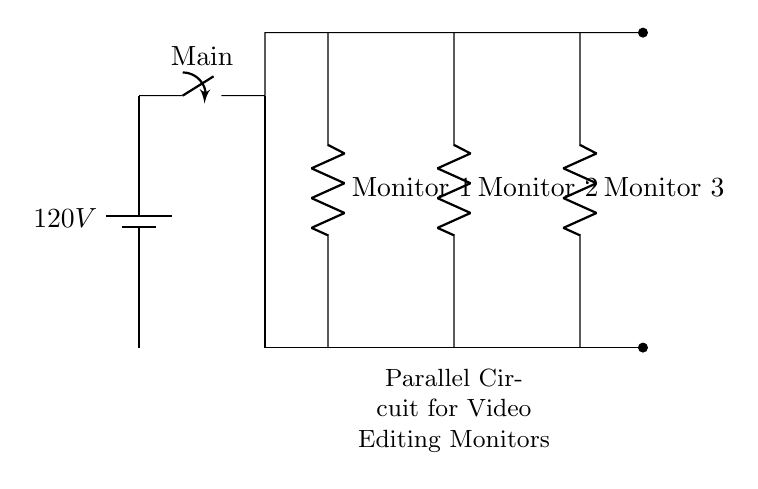What is the voltage of the power supply? The power supply voltage is indicated on the battery symbol in the circuit. It shows that the voltage is 120 volts.
Answer: 120 volts How many monitors are connected in parallel? The circuit diagram shows three distinct resistors labeled as Monitor 1, Monitor 2, and Monitor 3. Each represents a separate monitor connected in parallel.
Answer: Three What does the main switch control? The main switch is located at the top of the circuit diagram and controls the power supply to the entire circuit. If the switch is open, it will interrupt power to all monitors.
Answer: Power supply to all monitors How are the monitors connected in the circuit? The monitors are connected to the same voltage source, with each having individual branches stemming from the main circuit. This configuration allows each monitor to operate independently.
Answer: In parallel What happens to the voltage across each monitor? In a parallel circuit, the voltage across each resistor (monitor) is the same as the source voltage. Therefore, the voltage across each monitor will remain at 120 volts regardless of how many monitors are connected.
Answer: 120 volts What is the significance of using a parallel circuit for monitors? A parallel circuit allows each monitor to operate independently without affecting the others. If one monitor fails, the others will continue to function, providing reliability in a video editing suite.
Answer: Reliability 